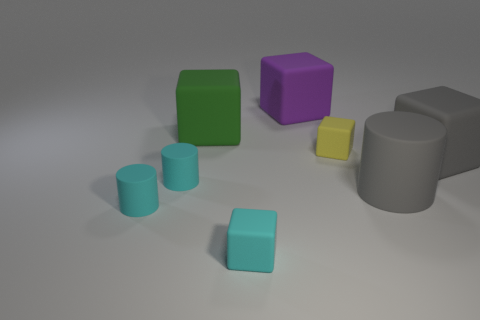Is the number of tiny objects right of the large purple matte block less than the number of matte cylinders that are to the left of the big green matte thing?
Provide a succinct answer. Yes. What size is the rubber thing that is behind the yellow rubber thing and in front of the purple matte thing?
Your response must be concise. Large. What is the shape of the gray matte object that is the same size as the gray rubber cube?
Give a very brief answer. Cylinder. Do the big matte thing that is left of the tiny cyan cube and the big thing behind the green block have the same shape?
Make the answer very short. Yes. How many other things are there of the same material as the big cylinder?
Provide a short and direct response. 7. Does the big cube in front of the small yellow thing have the same material as the tiny yellow block that is on the right side of the green block?
Ensure brevity in your answer.  Yes. The gray object that is the same material as the large gray cube is what shape?
Make the answer very short. Cylinder. What number of yellow objects are there?
Make the answer very short. 1. There is a large object that is both left of the gray block and in front of the tiny yellow matte block; what shape is it?
Give a very brief answer. Cylinder. The gray thing to the right of the large gray matte thing that is in front of the big rubber block that is to the right of the purple rubber thing is what shape?
Your answer should be compact. Cube. 